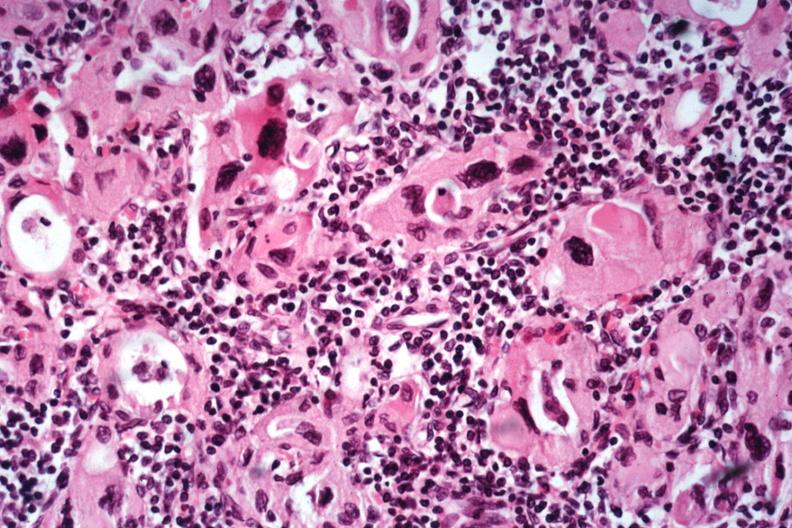s autoimmune thyroiditis present?
Answer the question using a single word or phrase. Yes 